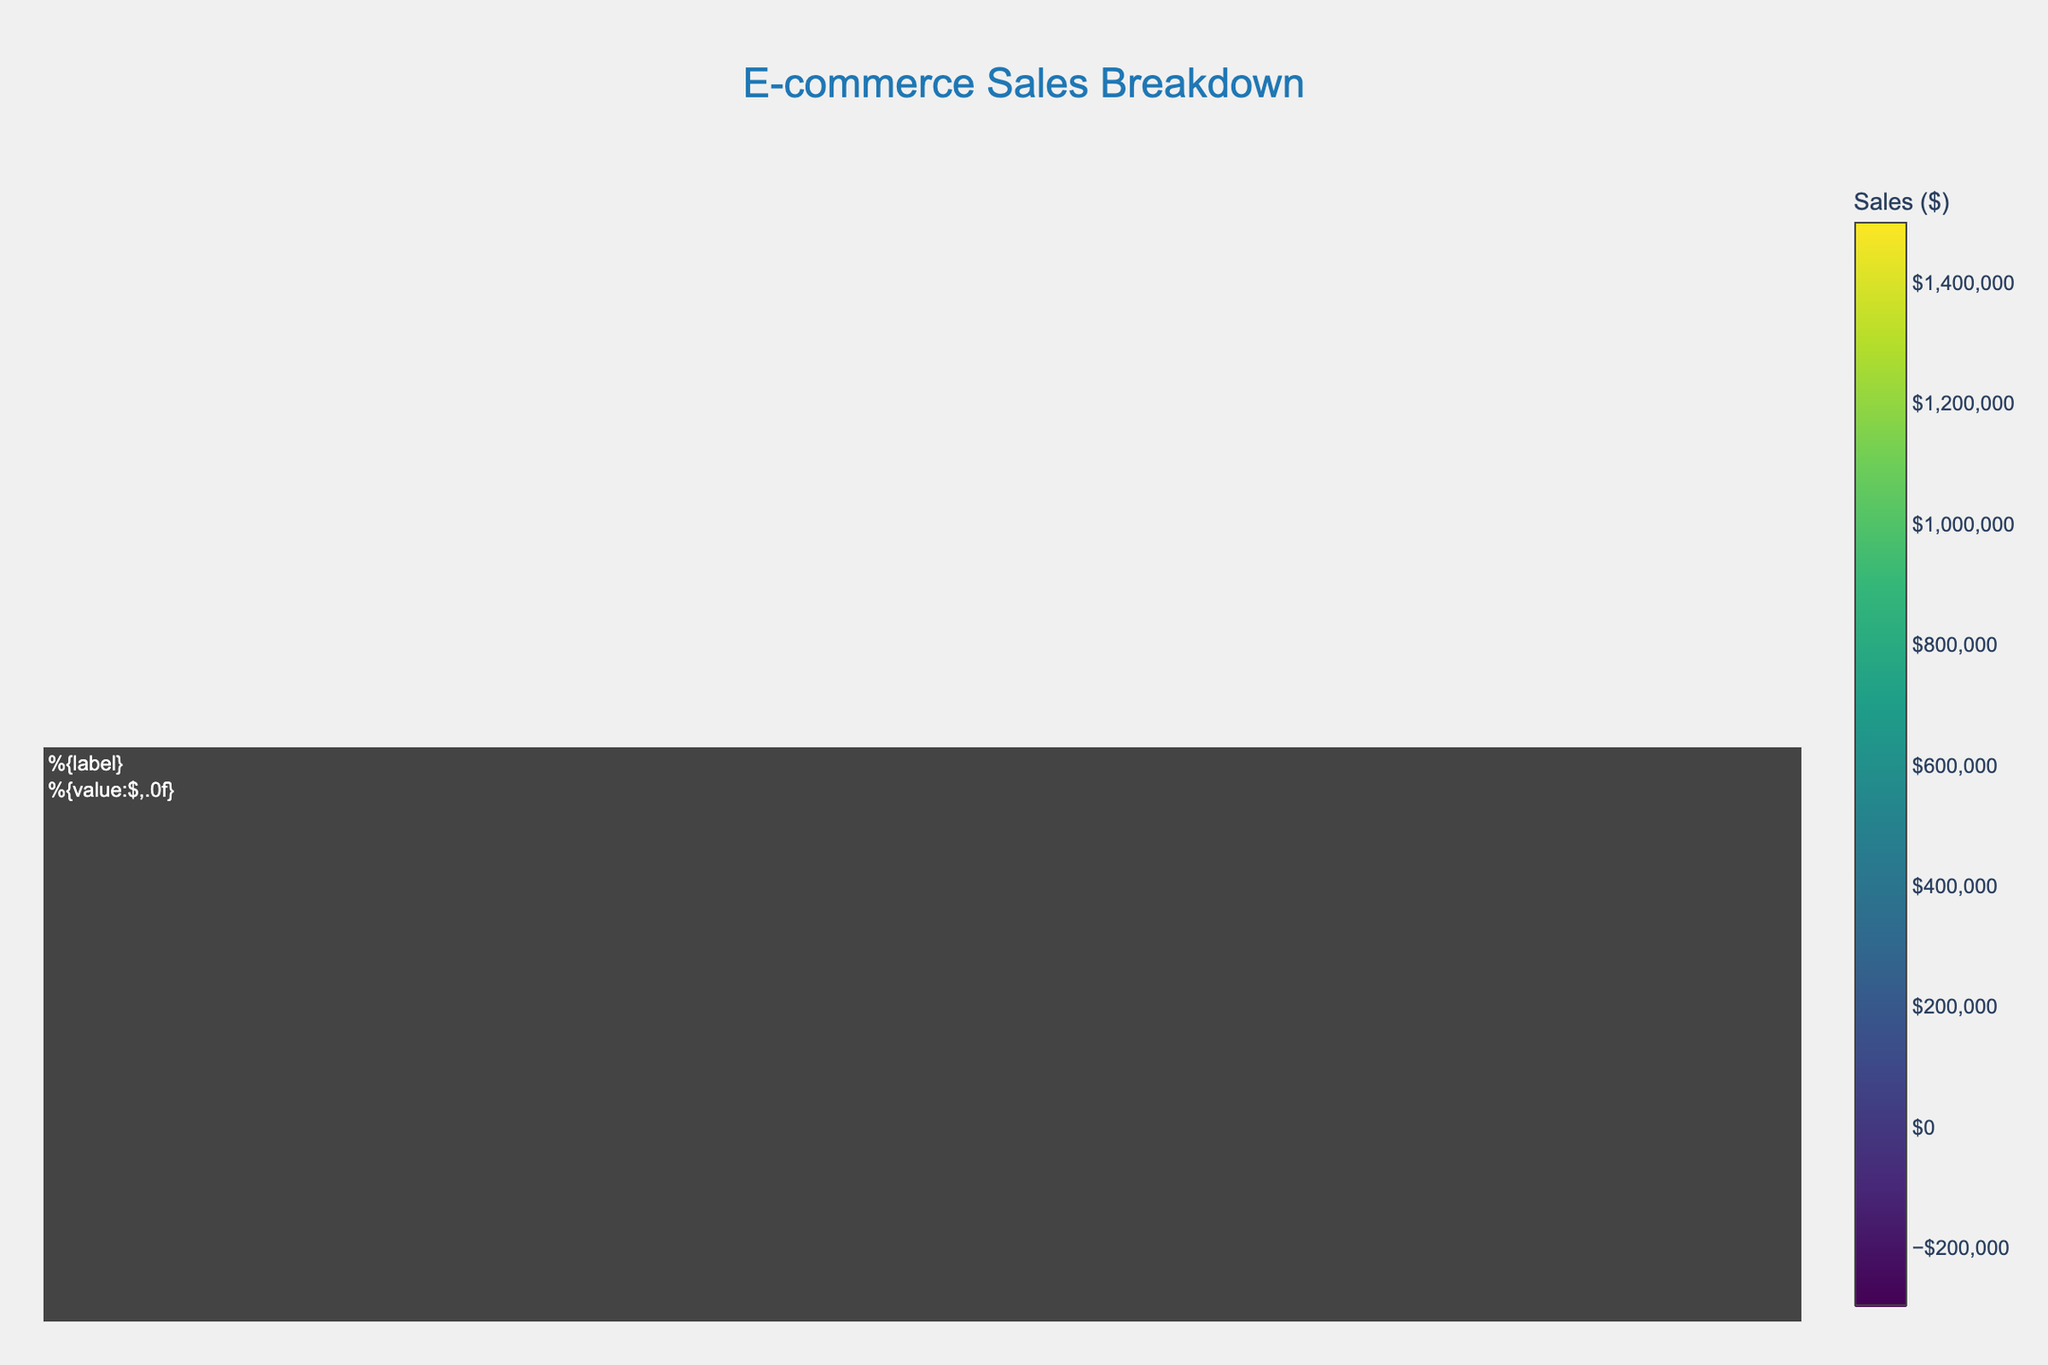What is the total sales amount for the Electronics category? Sum the sales of all subcategories and products within the Electronics category: (1,500,000 + 1,200,000 + 900,000 + 750,000 + 600,000 + 450,000) = 5,400,000
Answer: 5,400,000 Which product has the highest sales in the Clothing category? Compare the sales of all products in the Clothing category: T-shirts (800,000), Jeans (700,000), Dresses (950,000), Blouses (850,000), Sneakers (600,000), Boots (500,000). Dresses have the highest sales.
Answer: Dresses How much more are the sales of iPhone 13 compared to MacBook Air? Subtract the sales of MacBook Air from the sales of iPhone 13: 1,500,000 - 900,000 = 600,000
Answer: 600,000 Which subcategory in Home & Garden has the lowest sales? Compare the total sales of each subcategory in Home & Garden: Furniture (400,000 + 350,000), Appliances (550,000 + 500,000), Decor (250,000 + 200,000). Decor has the lowest sales (450,000).
Answer: Decor What is the average sales amount for the products in the Books category? Calculate the sum of sales for all products in the Books category, then divide by the number of products: (300,000 + 250,000 + 350,000 + 300,000) / 4 = 1,200,000 / 4 = 300,000
Answer: 300,000 What are the total sales for Women's Wear in the Clothing category? Sum the sales of Dresses and Blouses in Women's Wear: 950,000 + 850,000 = 1,800,000
Answer: 1,800,000 Which has higher sales: Samsung Galaxy S21 or MacBook Air? Compare the sales values of Samsung Galaxy S21 (1,200,000) and MacBook Air (900,000). Samsung Galaxy S21 has higher sales.
Answer: Samsung Galaxy S21 What is the combined sales amount of all products in the Home & Garden category? Sum the sales of all products in the Home & Garden category: 400,000 + 350,000 + 550,000 + 500,000 + 250,000 + 200,000 = 2,250,000
Answer: 2,250,000 How do sales of Tablets compare to Smartphones in the Electronics category? Sum the sales of Tablets (600,000 + 450,000 = 1,050,000) and Smartphones (1,500,000 + 1,200,000 = 2,700,000). Smartphones have higher sales.
Answer: Smartphones Which category has the highest total sales? Compare the total sales of each category: Electronics (5,400,000), Clothing (4,400,000), Home & Garden (2,250,000), Books (1,200,000). Electronics has the highest total sales.
Answer: Electronics 